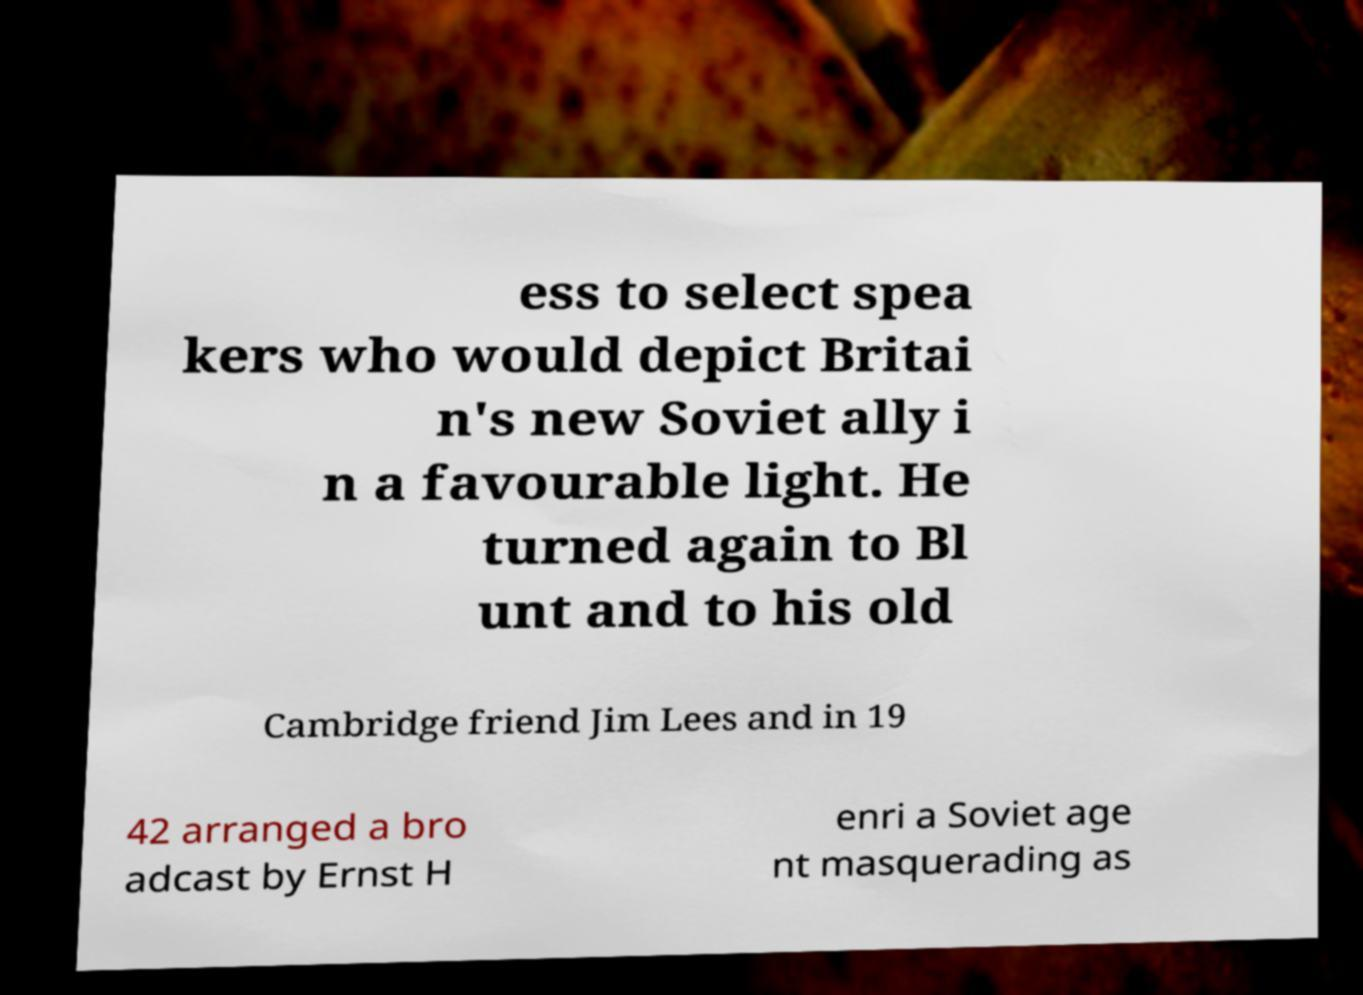Please read and relay the text visible in this image. What does it say? ess to select spea kers who would depict Britai n's new Soviet ally i n a favourable light. He turned again to Bl unt and to his old Cambridge friend Jim Lees and in 19 42 arranged a bro adcast by Ernst H enri a Soviet age nt masquerading as 